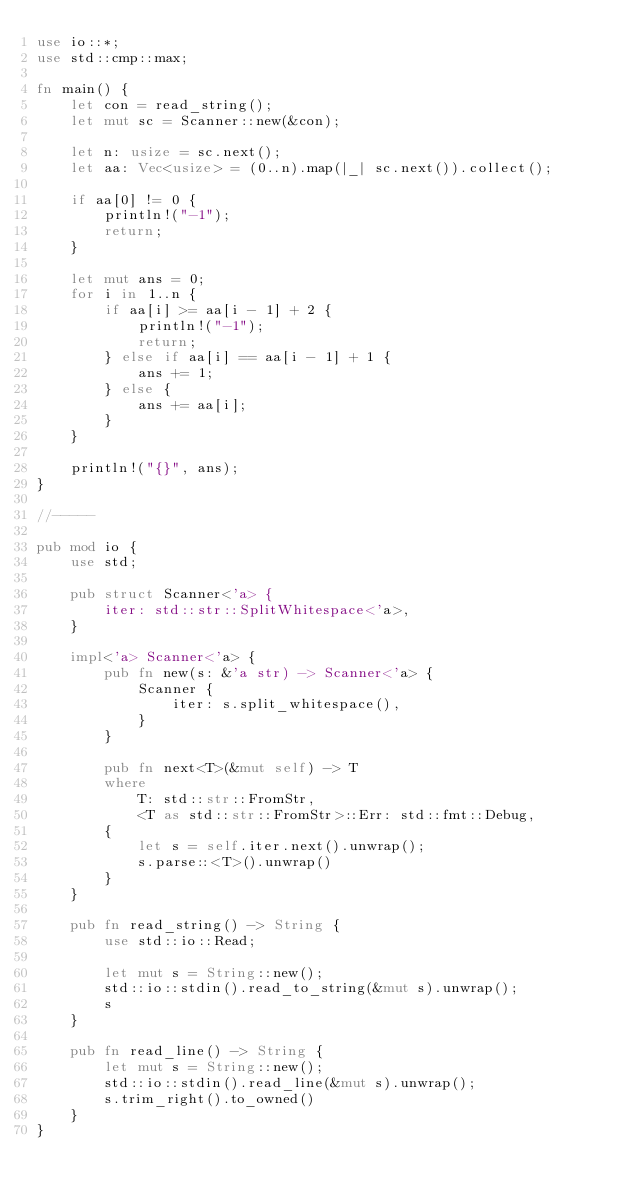<code> <loc_0><loc_0><loc_500><loc_500><_Rust_>use io::*;
use std::cmp::max;

fn main() {
    let con = read_string();
    let mut sc = Scanner::new(&con);

    let n: usize = sc.next();
    let aa: Vec<usize> = (0..n).map(|_| sc.next()).collect();

    if aa[0] != 0 {
        println!("-1");
        return;
    }

    let mut ans = 0;
    for i in 1..n {
        if aa[i] >= aa[i - 1] + 2 {
            println!("-1");
            return;
        } else if aa[i] == aa[i - 1] + 1 {
            ans += 1;
        } else {
            ans += aa[i];
        }
    }

    println!("{}", ans);
}

//-----

pub mod io {
    use std;

    pub struct Scanner<'a> {
        iter: std::str::SplitWhitespace<'a>,
    }

    impl<'a> Scanner<'a> {
        pub fn new(s: &'a str) -> Scanner<'a> {
            Scanner {
                iter: s.split_whitespace(),
            }
        }

        pub fn next<T>(&mut self) -> T
        where
            T: std::str::FromStr,
            <T as std::str::FromStr>::Err: std::fmt::Debug,
        {
            let s = self.iter.next().unwrap();
            s.parse::<T>().unwrap()
        }
    }

    pub fn read_string() -> String {
        use std::io::Read;

        let mut s = String::new();
        std::io::stdin().read_to_string(&mut s).unwrap();
        s
    }

    pub fn read_line() -> String {
        let mut s = String::new();
        std::io::stdin().read_line(&mut s).unwrap();
        s.trim_right().to_owned()
    }
}
</code> 